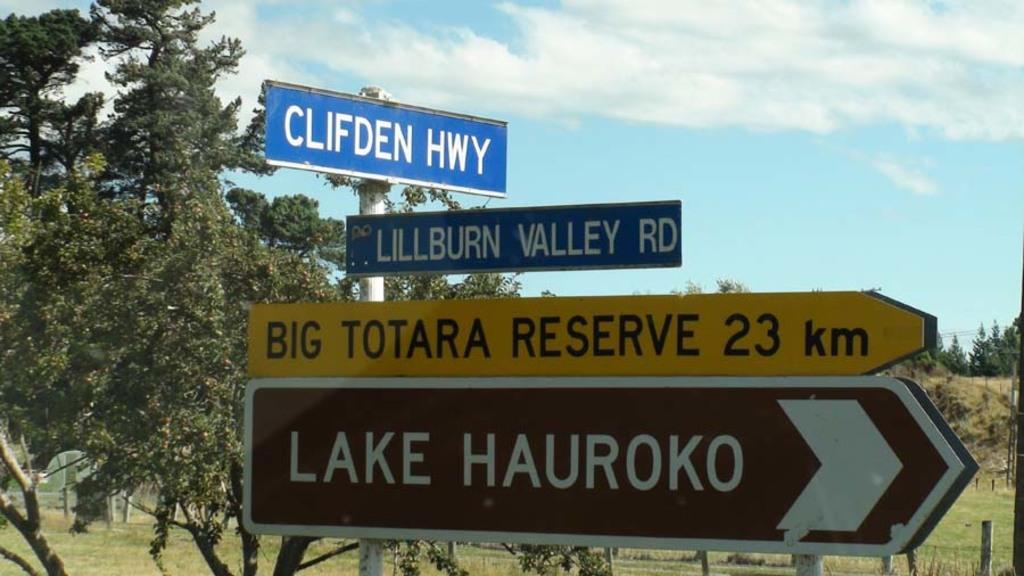What lake is nearby?
Provide a succinct answer. Lake hauroko. How far is the lake?
Keep it short and to the point. 23km. 